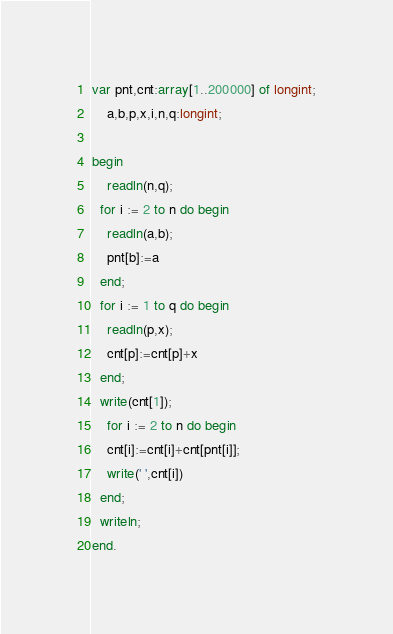Convert code to text. <code><loc_0><loc_0><loc_500><loc_500><_Pascal_>var pnt,cnt:array[1..200000] of longint;
    a,b,p,x,i,n,q:longint;

begin
	readln(n,q);
  for i := 2 to n do begin
    readln(a,b);
    pnt[b]:=a
  end;
  for i := 1 to q do begin
    readln(p,x);
    cnt[p]:=cnt[p]+x
  end;
  write(cnt[1]);
	for i := 2 to n do begin
    cnt[i]:=cnt[i]+cnt[pnt[i]];
    write(' ',cnt[i])
  end;
  writeln;
end.</code> 